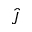Convert formula to latex. <formula><loc_0><loc_0><loc_500><loc_500>\hat { J }</formula> 